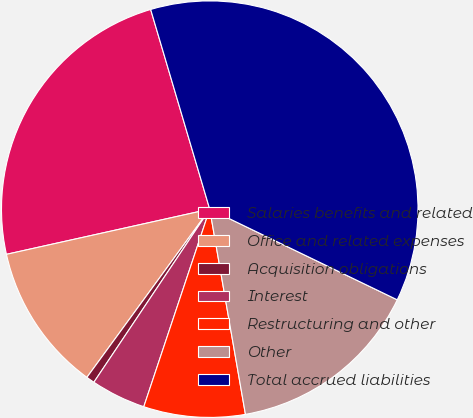Convert chart to OTSL. <chart><loc_0><loc_0><loc_500><loc_500><pie_chart><fcel>Salaries benefits and related<fcel>Office and related expenses<fcel>Acquisition obligations<fcel>Interest<fcel>Restructuring and other<fcel>Other<fcel>Total accrued liabilities<nl><fcel>23.9%<fcel>11.48%<fcel>0.65%<fcel>4.26%<fcel>7.87%<fcel>15.09%<fcel>36.74%<nl></chart> 